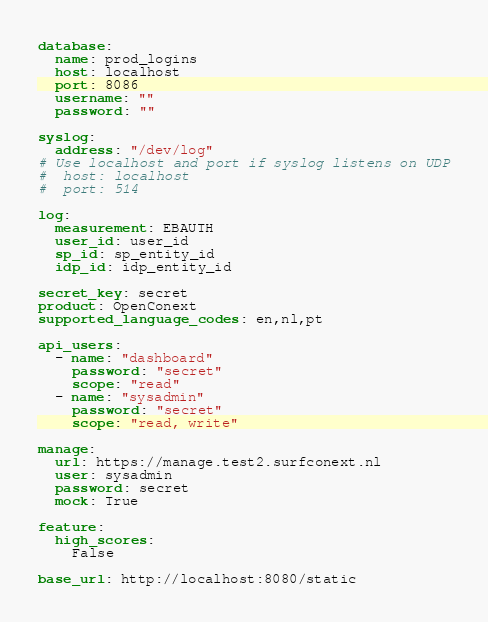<code> <loc_0><loc_0><loc_500><loc_500><_YAML_>database:
  name: prod_logins
  host: localhost
  port: 8086
  username: ""
  password: ""

syslog:
  address: "/dev/log"
# Use localhost and port if syslog listens on UDP
#  host: localhost
#  port: 514

log:
  measurement: EBAUTH
  user_id: user_id
  sp_id: sp_entity_id
  idp_id: idp_entity_id

secret_key: secret
product: OpenConext
supported_language_codes: en,nl,pt

api_users:
  - name: "dashboard"
    password: "secret"
    scope: "read"
  - name: "sysadmin"
    password: "secret"
    scope: "read, write"

manage:
  url: https://manage.test2.surfconext.nl
  user: sysadmin
  password: secret
  mock: True

feature:
  high_scores:
    False

base_url: http://localhost:8080/static</code> 